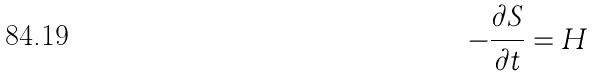Convert formula to latex. <formula><loc_0><loc_0><loc_500><loc_500>- \frac { \partial S } { \partial t } = H</formula> 